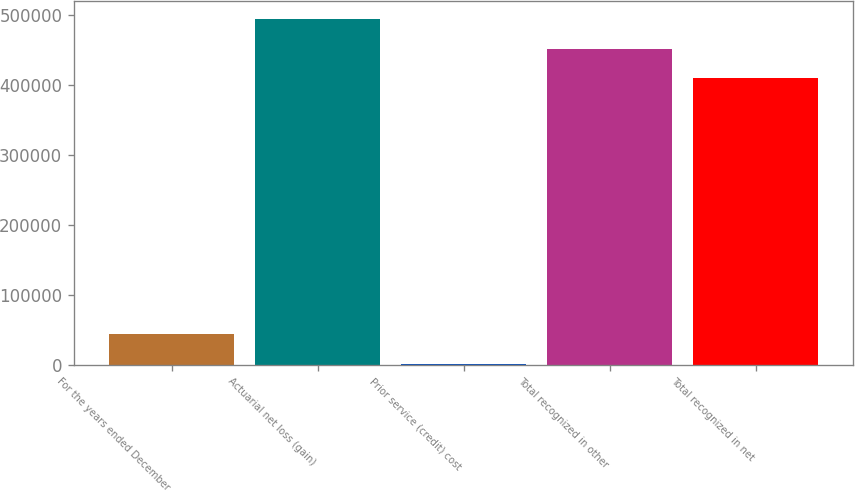Convert chart to OTSL. <chart><loc_0><loc_0><loc_500><loc_500><bar_chart><fcel>For the years ended December<fcel>Actuarial net loss (gain)<fcel>Prior service (credit) cost<fcel>Total recognized in other<fcel>Total recognized in net<nl><fcel>43674.5<fcel>495442<fcel>941<fcel>452708<fcel>409975<nl></chart> 